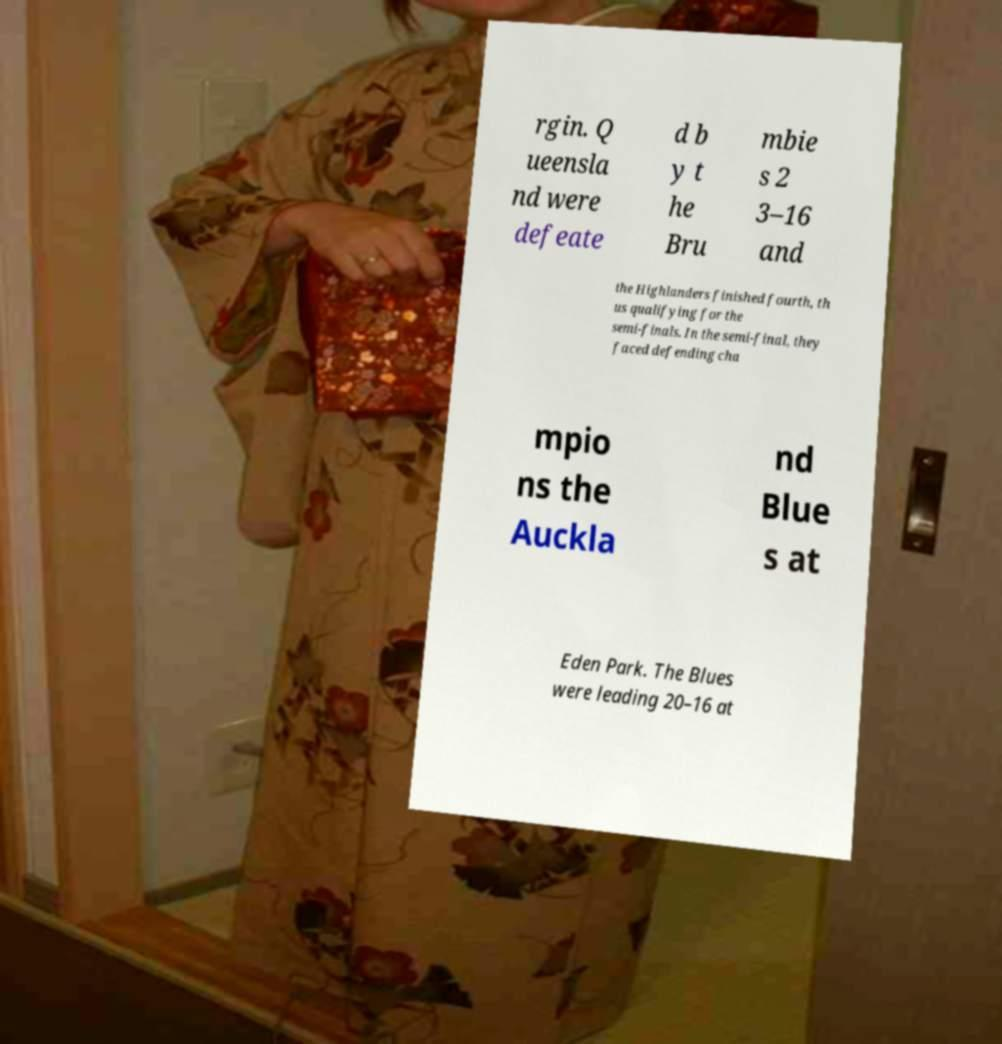Please read and relay the text visible in this image. What does it say? rgin. Q ueensla nd were defeate d b y t he Bru mbie s 2 3–16 and the Highlanders finished fourth, th us qualifying for the semi-finals. In the semi-final, they faced defending cha mpio ns the Auckla nd Blue s at Eden Park. The Blues were leading 20–16 at 